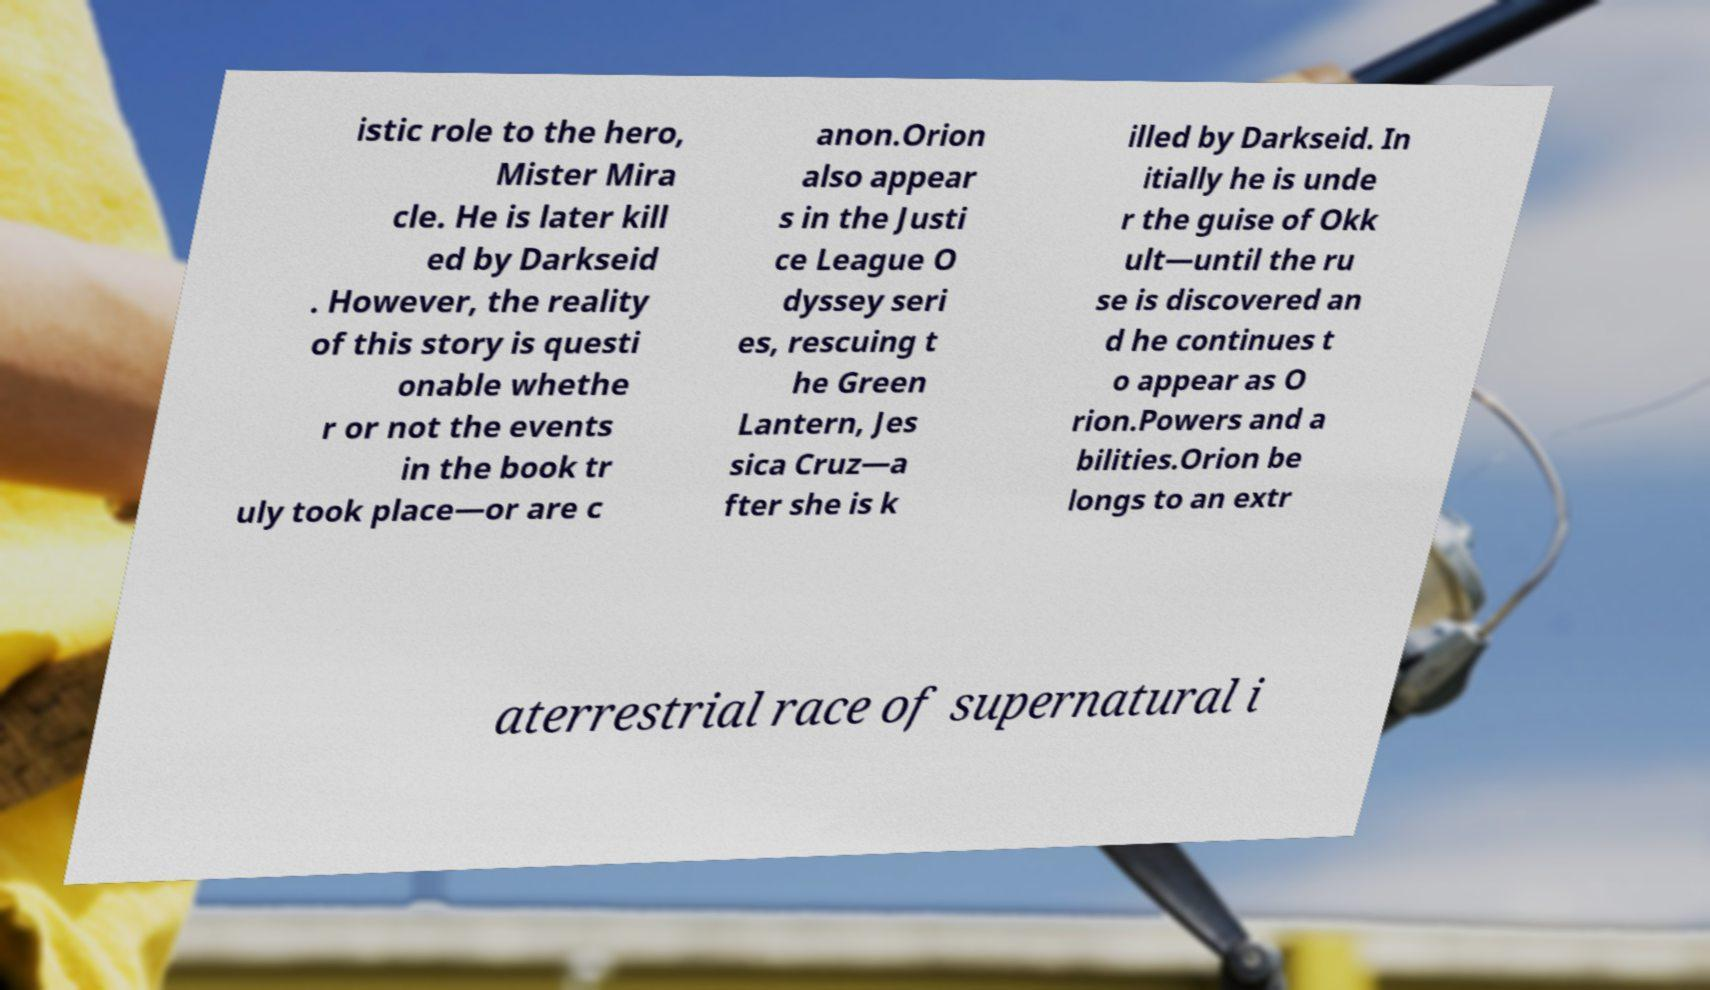There's text embedded in this image that I need extracted. Can you transcribe it verbatim? istic role to the hero, Mister Mira cle. He is later kill ed by Darkseid . However, the reality of this story is questi onable whethe r or not the events in the book tr uly took place—or are c anon.Orion also appear s in the Justi ce League O dyssey seri es, rescuing t he Green Lantern, Jes sica Cruz—a fter she is k illed by Darkseid. In itially he is unde r the guise of Okk ult—until the ru se is discovered an d he continues t o appear as O rion.Powers and a bilities.Orion be longs to an extr aterrestrial race of supernatural i 